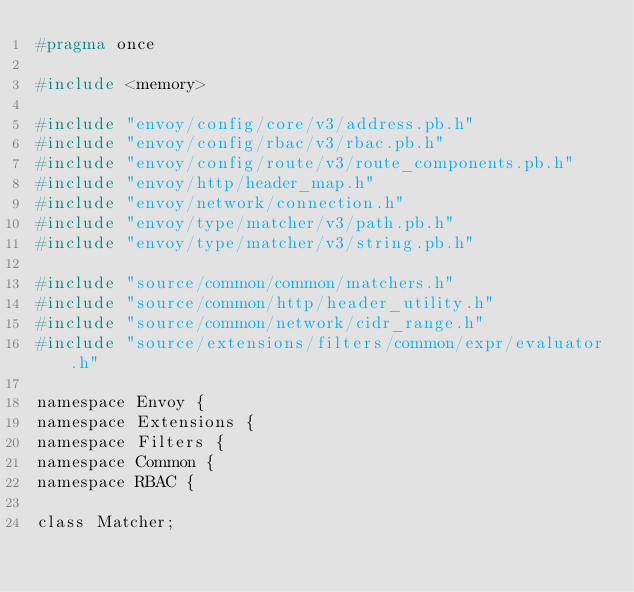Convert code to text. <code><loc_0><loc_0><loc_500><loc_500><_C_>#pragma once

#include <memory>

#include "envoy/config/core/v3/address.pb.h"
#include "envoy/config/rbac/v3/rbac.pb.h"
#include "envoy/config/route/v3/route_components.pb.h"
#include "envoy/http/header_map.h"
#include "envoy/network/connection.h"
#include "envoy/type/matcher/v3/path.pb.h"
#include "envoy/type/matcher/v3/string.pb.h"

#include "source/common/common/matchers.h"
#include "source/common/http/header_utility.h"
#include "source/common/network/cidr_range.h"
#include "source/extensions/filters/common/expr/evaluator.h"

namespace Envoy {
namespace Extensions {
namespace Filters {
namespace Common {
namespace RBAC {

class Matcher;</code> 